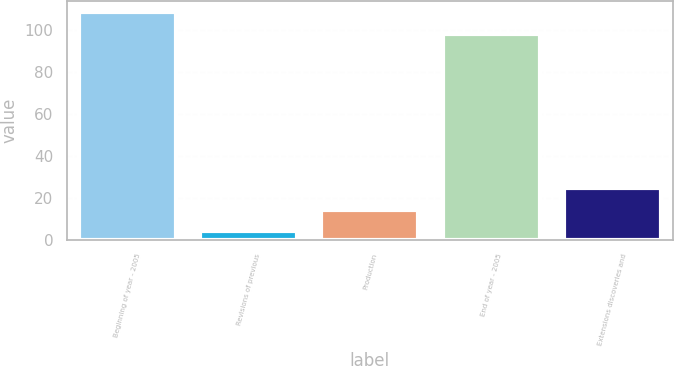Convert chart. <chart><loc_0><loc_0><loc_500><loc_500><bar_chart><fcel>Beginning of year - 2005<fcel>Revisions of previous<fcel>Production<fcel>End of year - 2005<fcel>Extensions discoveries and<nl><fcel>108.3<fcel>4<fcel>14.3<fcel>98<fcel>24.6<nl></chart> 